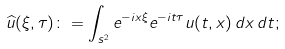<formula> <loc_0><loc_0><loc_500><loc_500>\widehat { u } ( \xi , \tau ) \colon = \int _ { \real s ^ { 2 } } e ^ { - i x \xi } e ^ { - i t \tau } u ( t , x ) \, d x \, d t ;</formula> 